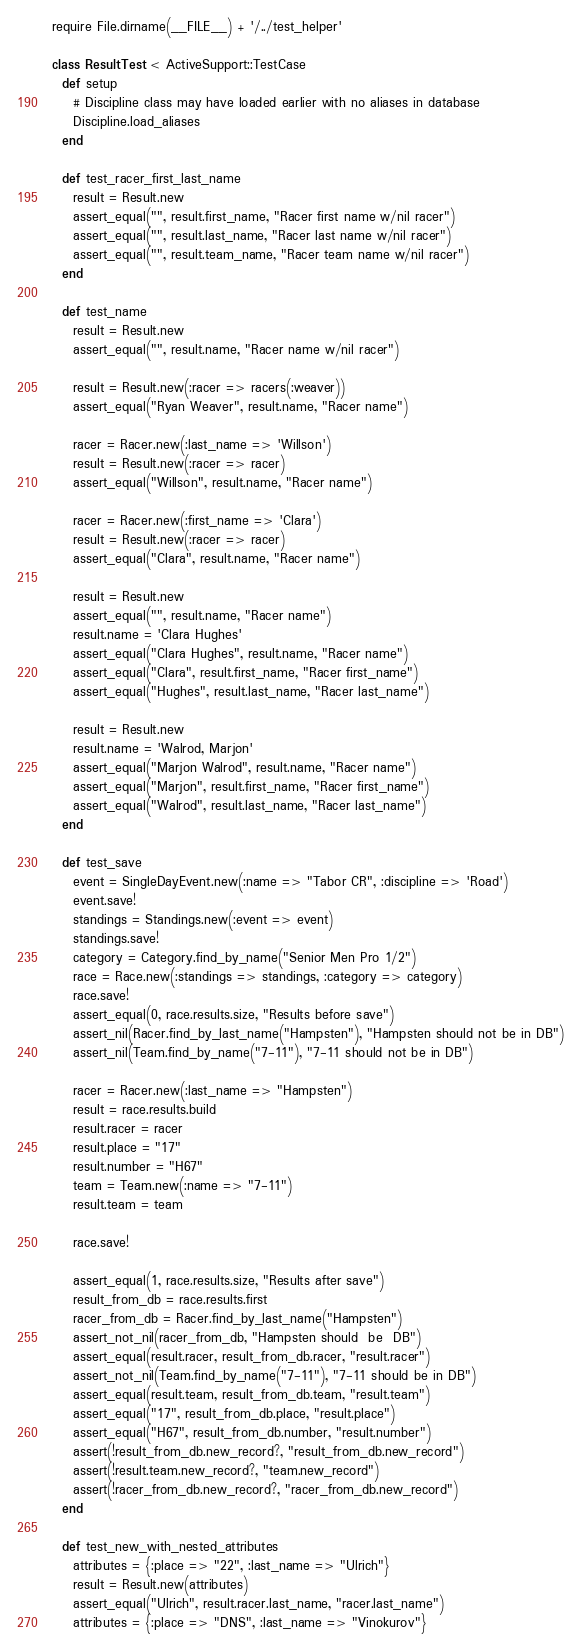Convert code to text. <code><loc_0><loc_0><loc_500><loc_500><_Ruby_>require File.dirname(__FILE__) + '/../test_helper'

class ResultTest < ActiveSupport::TestCase
  def setup
    # Discipline class may have loaded earlier with no aliases in database
    Discipline.load_aliases
  end
  
  def test_racer_first_last_name
    result = Result.new
    assert_equal("", result.first_name, "Racer first name w/nil racer")
    assert_equal("", result.last_name, "Racer last name w/nil racer")
    assert_equal("", result.team_name, "Racer team name w/nil racer")
  end
  
  def test_name
    result = Result.new
    assert_equal("", result.name, "Racer name w/nil racer")
    
    result = Result.new(:racer => racers(:weaver))
    assert_equal("Ryan Weaver", result.name, "Racer name")
    
    racer = Racer.new(:last_name => 'Willson')
    result = Result.new(:racer => racer)
    assert_equal("Willson", result.name, "Racer name")
    
    racer = Racer.new(:first_name => 'Clara')
    result = Result.new(:racer => racer)
    assert_equal("Clara", result.name, "Racer name")

    result = Result.new
    assert_equal("", result.name, "Racer name")
    result.name = 'Clara Hughes'
    assert_equal("Clara Hughes", result.name, "Racer name")
    assert_equal("Clara", result.first_name, "Racer first_name")
    assert_equal("Hughes", result.last_name, "Racer last_name")

    result = Result.new
    result.name = 'Walrod, Marjon'
    assert_equal("Marjon Walrod", result.name, "Racer name")
    assert_equal("Marjon", result.first_name, "Racer first_name")
    assert_equal("Walrod", result.last_name, "Racer last_name")
  end

  def test_save
    event = SingleDayEvent.new(:name => "Tabor CR", :discipline => 'Road')
    event.save!
    standings = Standings.new(:event => event)
    standings.save!
    category = Category.find_by_name("Senior Men Pro 1/2")
    race = Race.new(:standings => standings, :category => category)
    race.save!
    assert_equal(0, race.results.size, "Results before save")
    assert_nil(Racer.find_by_last_name("Hampsten"), "Hampsten should not be in DB")
    assert_nil(Team.find_by_name("7-11"), "7-11 should not be in DB")
    
    racer = Racer.new(:last_name => "Hampsten")
    result = race.results.build
    result.racer = racer    
    result.place = "17"
    result.number = "H67"
    team = Team.new(:name => "7-11")
    result.team = team

    race.save!

    assert_equal(1, race.results.size, "Results after save")
    result_from_db = race.results.first
    racer_from_db = Racer.find_by_last_name("Hampsten")
    assert_not_nil(racer_from_db, "Hampsten should  be  DB")
    assert_equal(result.racer, result_from_db.racer, "result.racer")
    assert_not_nil(Team.find_by_name("7-11"), "7-11 should be in DB")
    assert_equal(result.team, result_from_db.team, "result.team")
    assert_equal("17", result_from_db.place, "result.place")
    assert_equal("H67", result_from_db.number, "result.number")
    assert(!result_from_db.new_record?, "result_from_db.new_record")
    assert(!result.team.new_record?, "team.new_record")
    assert(!racer_from_db.new_record?, "racer_from_db.new_record")
  end

  def test_new_with_nested_attributes
    attributes = {:place => "22", :last_name => "Ulrich"}
    result = Result.new(attributes)
    assert_equal("Ulrich", result.racer.last_name, "racer.last_name")
    attributes = {:place => "DNS", :last_name => "Vinokurov"}</code> 